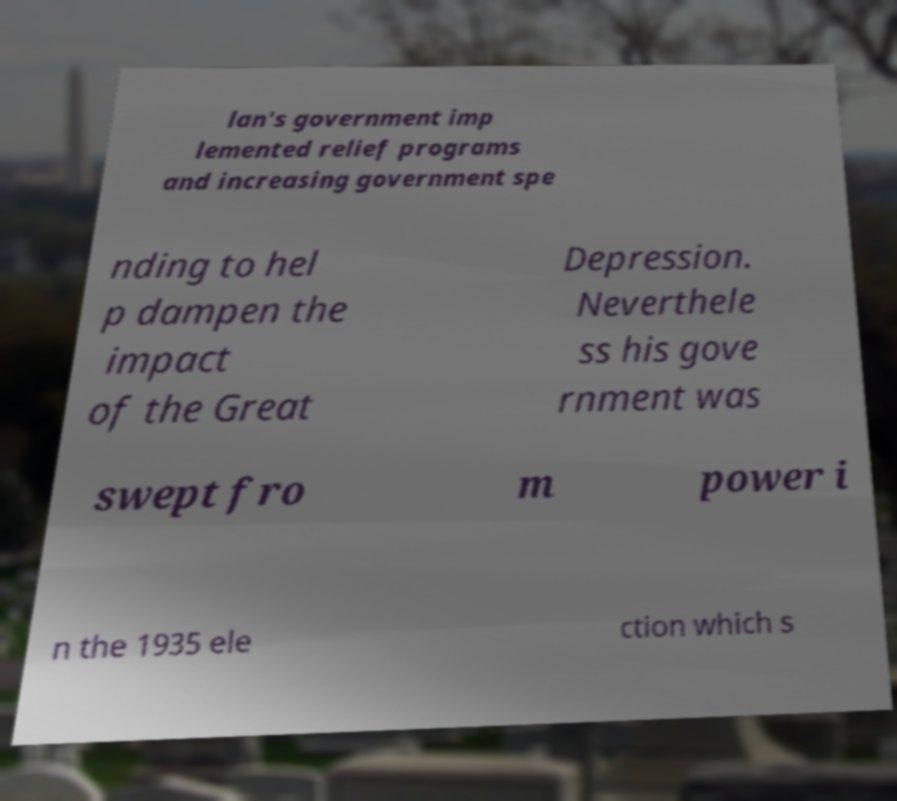Could you extract and type out the text from this image? lan's government imp lemented relief programs and increasing government spe nding to hel p dampen the impact of the Great Depression. Neverthele ss his gove rnment was swept fro m power i n the 1935 ele ction which s 